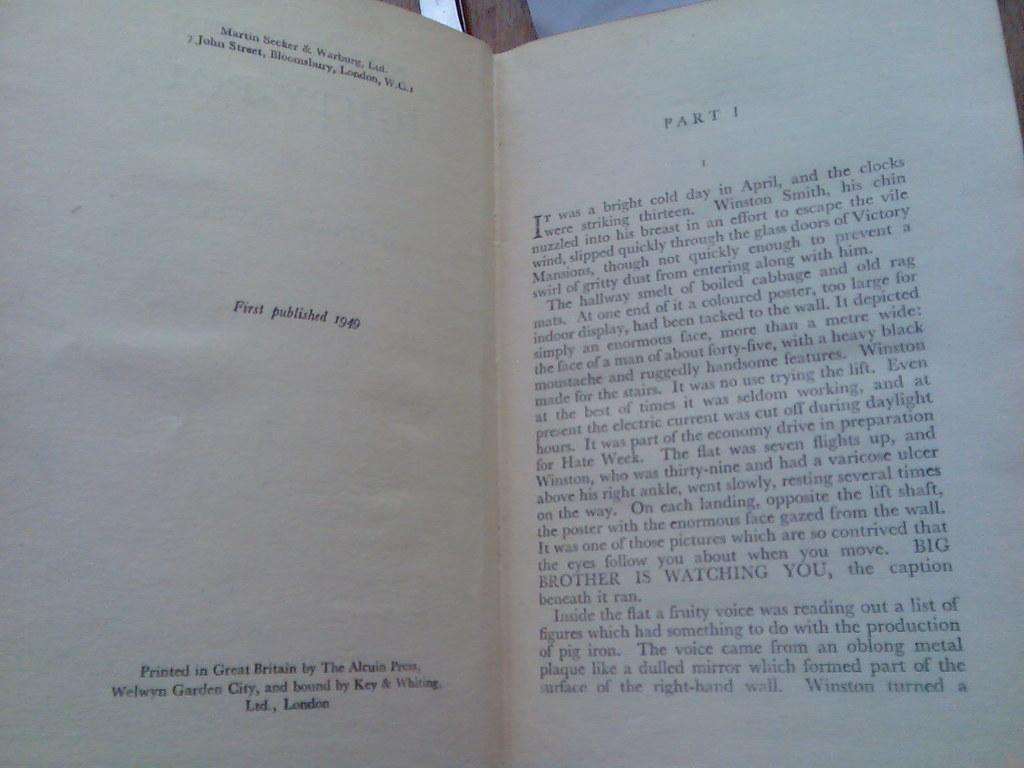<image>
Describe the image concisely. Part one of a chapter book that was first published in 1949 